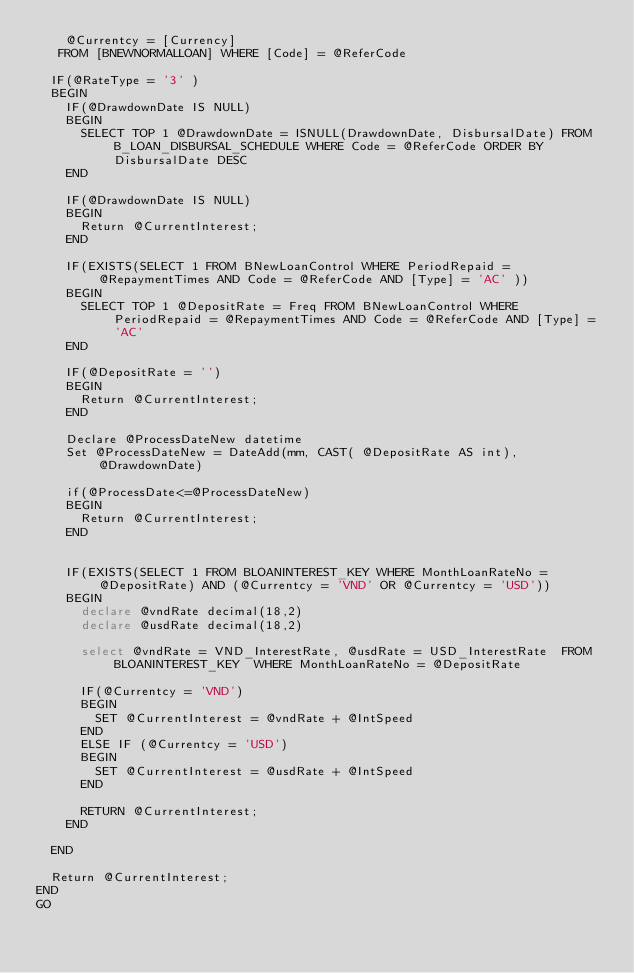Convert code to text. <code><loc_0><loc_0><loc_500><loc_500><_SQL_>		@Currentcy = [Currency]
	 FROM [BNEWNORMALLOAN] WHERE [Code] = @ReferCode

	IF(@RateType = '3' )
	BEGIN
		IF(@DrawdownDate IS NULL)
		BEGIN
			SELECT TOP 1 @DrawdownDate = ISNULL(DrawdownDate, DisbursalDate) FROM B_LOAN_DISBURSAL_SCHEDULE WHERE Code = @ReferCode ORDER BY DisbursalDate DESC
		END

		IF(@DrawdownDate IS NULL)
		BEGIN
			Return @CurrentInterest;
		END

		IF(EXISTS(SELECT 1 FROM BNewLoanControl WHERE PeriodRepaid = @RepaymentTimes AND Code = @ReferCode AND [Type] = 'AC' ))
		BEGIN
			SELECT TOP 1 @DepositRate = Freq FROM BNewLoanControl WHERE PeriodRepaid = @RepaymentTimes AND Code = @ReferCode AND [Type] = 'AC' 
		END

		IF(@DepositRate = '')
		BEGIN
			Return @CurrentInterest;
		END 

		Declare @ProcessDateNew datetime
		Set @ProcessDateNew = DateAdd(mm, CAST( @DepositRate AS int), @DrawdownDate)

		if(@ProcessDate<=@ProcessDateNew)
		BEGIN
			Return @CurrentInterest;
		END


		IF(EXISTS(SELECT 1 FROM BLOANINTEREST_KEY WHERE MonthLoanRateNo = @DepositRate) AND (@Currentcy = 'VND' OR @Currentcy = 'USD'))
		BEGIN
			declare @vndRate decimal(18,2)
			declare @usdRate decimal(18,2)

			select @vndRate = VND_InterestRate, @usdRate = USD_InterestRate  FROM BLOANINTEREST_KEY  WHERE MonthLoanRateNo = @DepositRate

			IF(@Currentcy = 'VND')
			BEGIN
				SET @CurrentInterest = @vndRate + @IntSpeed
			END
			ELSE IF (@Currentcy = 'USD')
			BEGIN
				SET @CurrentInterest = @usdRate + @IntSpeed
			END
			
			RETURN @CurrentInterest;
		END

	END	

	Return @CurrentInterest;
END
GO</code> 